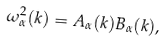Convert formula to latex. <formula><loc_0><loc_0><loc_500><loc_500>\omega _ { \alpha } ^ { 2 } ( k ) = A _ { \alpha } ( k ) B _ { \alpha } ( k ) ,</formula> 